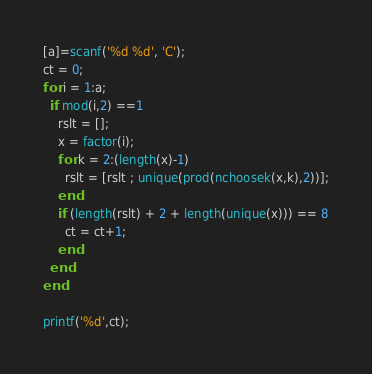<code> <loc_0><loc_0><loc_500><loc_500><_Octave_>[a]=scanf('%d %d', 'C');
ct = 0;
for i = 1:a;
  if mod(i,2) ==1
    rslt = [];
    x = factor(i);
  	for k = 2:(length(x)-1)
      rslt = [rslt ; unique(prod(nchoosek(x,k),2))];
    end
    if (length(rslt) + 2 + length(unique(x))) == 8
      ct = ct+1;
    end
  end
end

printf('%d',ct);</code> 